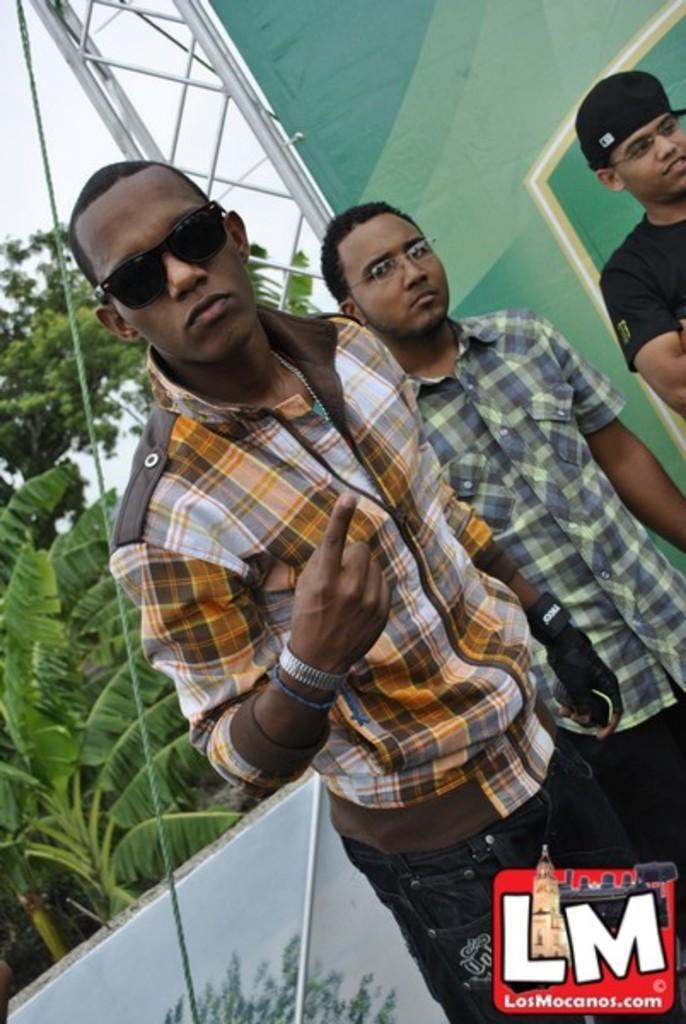Describe this image in one or two sentences. In this image we can see this person wearing shirt and glasses is standing here, this person wearing shirt and spectacles standing here and this person wearing black T-shirt, spectacles and cap is standing here. Here we can see the wall, plants, rope banner, trees and the sky in the background. At the bottom right side of the image we can see a logo. 